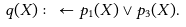Convert formula to latex. <formula><loc_0><loc_0><loc_500><loc_500>q ( X ) \colon \gets p _ { 1 } ( X ) \lor p _ { 3 } ( X ) . \\</formula> 